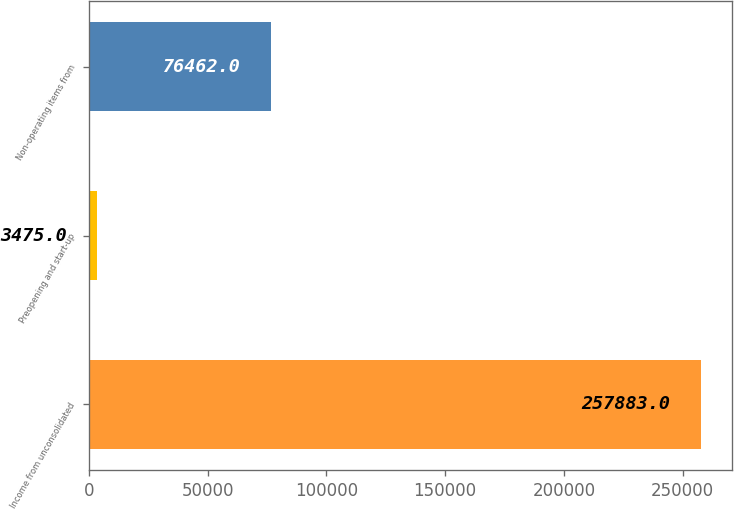Convert chart to OTSL. <chart><loc_0><loc_0><loc_500><loc_500><bar_chart><fcel>Income from unconsolidated<fcel>Preopening and start-up<fcel>Non-operating items from<nl><fcel>257883<fcel>3475<fcel>76462<nl></chart> 